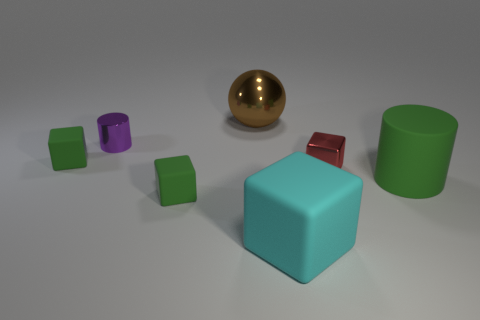Subtract all large cyan rubber blocks. How many blocks are left? 3 Add 2 big red rubber objects. How many objects exist? 9 Subtract 2 cubes. How many cubes are left? 2 Subtract all red blocks. How many blocks are left? 3 Subtract all green balls. How many green blocks are left? 2 Subtract all cylinders. How many objects are left? 5 Subtract all red blocks. Subtract all gray cylinders. How many blocks are left? 3 Add 3 tiny purple things. How many tiny purple things are left? 4 Add 7 large brown metallic spheres. How many large brown metallic spheres exist? 8 Subtract 0 gray blocks. How many objects are left? 7 